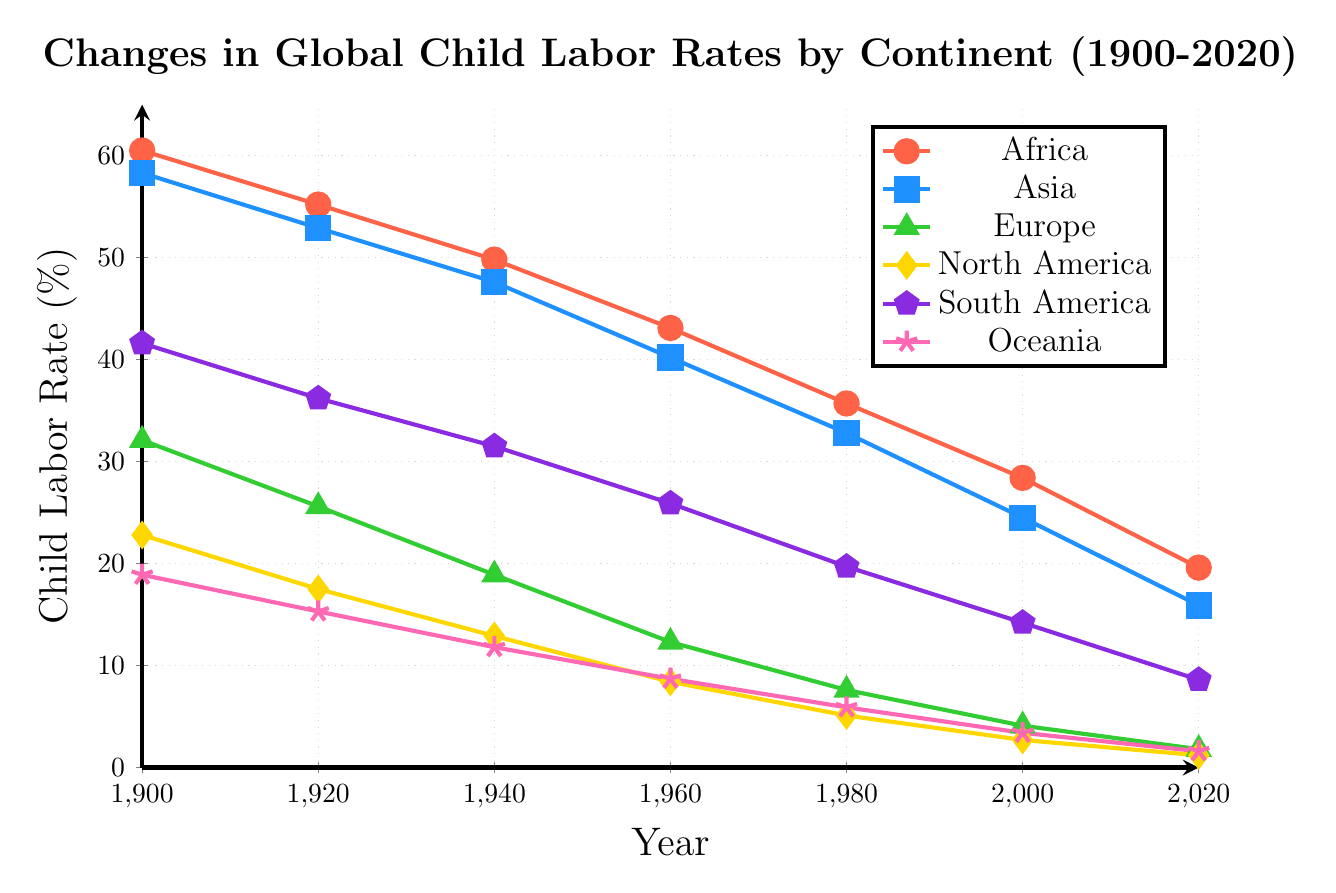What's the overall trend in child labor rates for Africa from 1900 to 2020? The line for Africa shows a continuous downward trend from 1900 (60.5%) to 2020 (19.6%). Each point represents a decreasing value over the years.
Answer: Downward trend Which continent had the highest child labor rate in 1920? By examining the points for each continent in 1920, Africa had the highest child labor rate at 55.2%.
Answer: Africa Compare the decline in child labor rates between Asia and Europe from 1900 to 2020. The decline in Asia is from 58.3% to 15.9%, a difference of 42.4%. In Europe, it declined from 32.1% to 1.8%, a difference of 30.3%. Asia had a larger absolute decline in child labor rates.
Answer: Asia Which continent witnessed the smallest change in child labor rates between 1900 and 2020? Oceania's child labor rate declined from 18.9% to 1.6%, a difference of 17.3%, which is the smallest change among all the continents.
Answer: Oceania In which year did South America have a child labor rate closest to the child labor rate of Europe in 1900? South America had a child labor rate of 31.5% in 1940, which is closest to Europe's 32.1% in 1900.
Answer: 1940 What is the approximate average child labor rate for North America from 1900 to 2020? The average is calculated as (22.8 + 17.5 + 12.9 + 8.4 + 5.1 + 2.7 + 1.2) / 7. The sum is 70.6, so the average is 70.6 / 7 = 10.1%.
Answer: 10.1% How did the child labor rate in Europe change between 1980 and 2000? In 1980, Europe's child labor rate was 7.6%. By 2000, it decreased to 4.1%. So the change is 7.6% - 4.1% = 3.5%.
Answer: Decreased by 3.5% Which continent showed the steepest decline in child labor rates between 1960 and 1980? By looking at the slopes between 1960 and 1980, Asia decreased from 40.2% to 32.8%, a change of 7.4%. Africa went from 43.1% to 35.7%, a change of 7.4%.
Answer: Asia and Africa Identify the continent with the lowest child labor rate in the year 2000. By examining the points for the year 2000, Europe had the lowest child labor rate at 4.1%.
Answer: Europe 